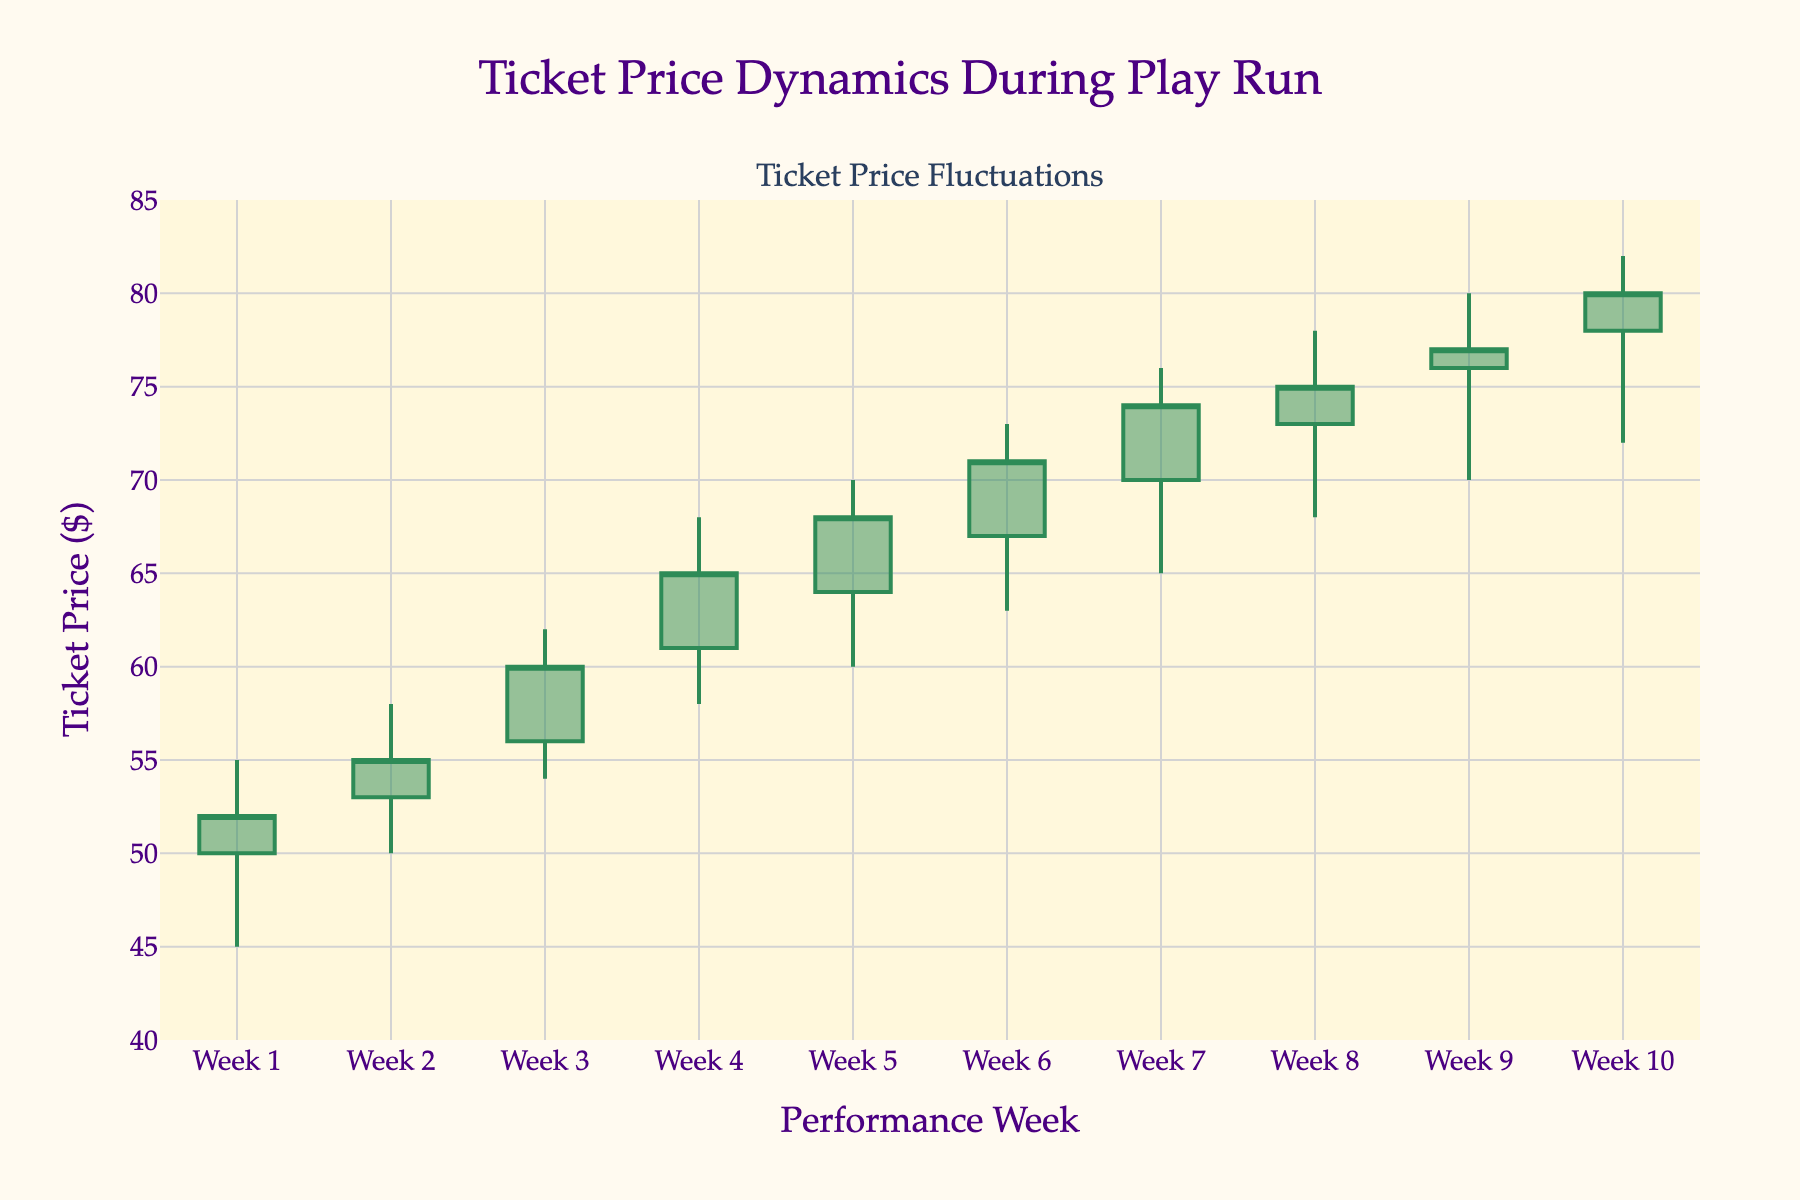What is the title of the plot? The title of the plot is located at the top center of the figure and presents the main subject of the visualization.
Answer: Ticket Price Dynamics During Play Run What is the average closing ticket price over the 10 weeks? First, sum all the closing prices: (52 + 55 + 60 + 65 + 68 + 71 + 74 + 75 + 77 + 80 = 677). Then, divide by the number of weeks (10) to find the average: 677 / 10.
Answer: 67.7 In which week did the ticket price have the highest increase from open to close? Calculate the difference between the open and close prices for each week, and identify the maximum change: Week 1: 52 - 50 = 2, Week 2: 55 - 53 = 2, Week 3: 60 - 56 = 4, Week 4: 65 - 61 = 4, Week 5: 68 - 64 = 4, Week 6: 71 - 67 = 4, Week 7: 74 - 70 = 4, Week 8: 75 - 73 = 2, Week 9: 77 - 76 = 1, Week 10: 80 - 78 = 2.
Answer: Week 3, Week 4, Week 5, Week 6, Week 7 Which week shows the highest volatility in ticket prices? Volatility can be measured by the difference between the high and low prices. Calculate this for each week and identify the maximum difference: Week 1: 55 - 45 = 10, Week 2: 58 - 50 = 8, Week 3: 62 - 54 = 8, Week 4: 68 - 58 = 10, Week 5: 70 - 60 = 10, Week 6: 73 - 63 = 10, Week 7: 76 - 65 = 11, Week 8: 78 - 68 = 10, Week 9: 80 - 70 = 10, Week 10: 82 - 72 = 10. The largest difference is 11.
Answer: Week 7 How does the color of the candlestick bars indicate price movement? The plot uses two different colors for candlestick bars: sea green for increasing and saddle brown for decreasing ticket prices. Green indicates the closing price is higher than the opening price, while brown indicates the closing price is lower than the opening price.
Answer: Green is an increase; Brown is a decrease During which week did the lowest ticket price occur? Identify the lowest 'Low' value across all weeks: the 'Low' values are 45 (Week 1), 50 (Week 2), 54 (Week 3), 58 (Week 4), 60 (Week 5), 63 (Week 6), 65 (Week 7), 68 (Week 8), 70 (Week 9), 72 (Week 10). The lowest value is 45.
Answer: Week 1 What is the range of ticket prices in Week 5? The range is determined by subtracting the lowest price from the highest price in Week 5: 70 (high) - 60 (low) = 10.
Answer: 10 Which week has the smallest difference between the high and low ticket prices? Calculate the difference between high and low for each week: Week 1: 10, Week 2: 8, Week 3: 8, Week 4: 10, Week 5: 10, Week 6: 10, Week 7: 11, Week 8: 10, Week 9: 10, Week 10: 10. The smallest difference is 8, which occurs in Week 2 and Week 3.
Answer: Week 2, Week 3 